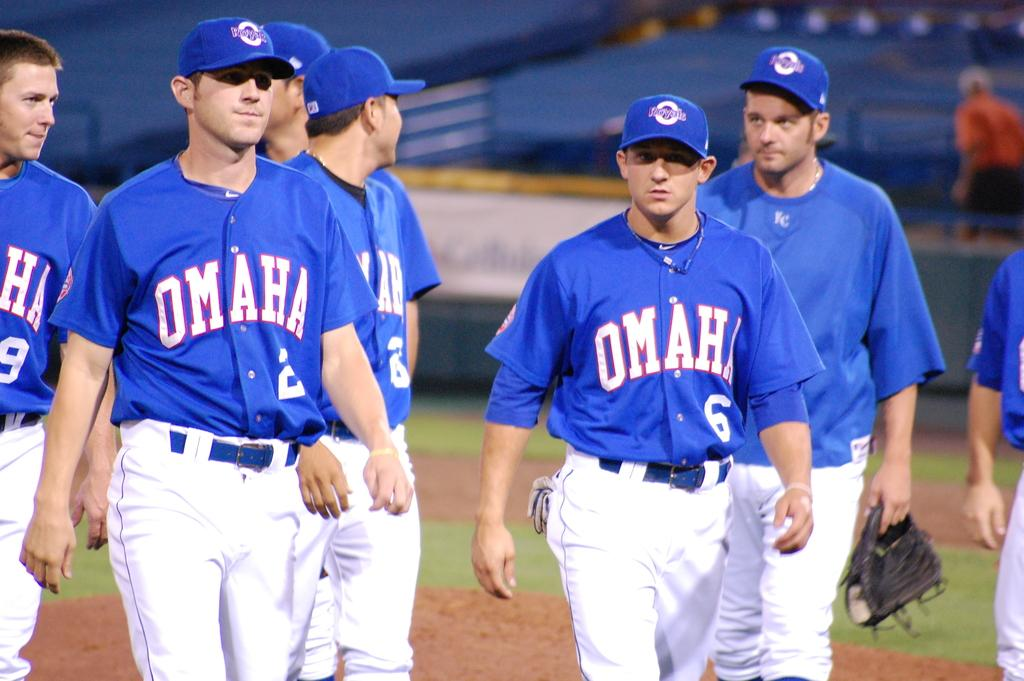Provide a one-sentence caption for the provided image. Several baseball players from the Omaha team are walking on the field. 